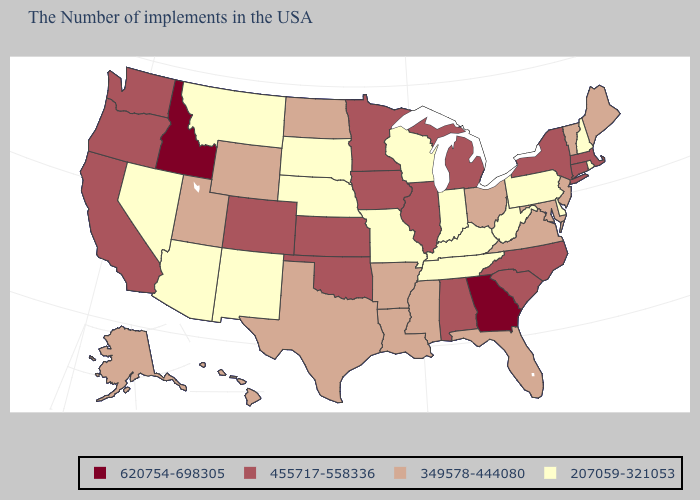What is the highest value in the MidWest ?
Write a very short answer. 455717-558336. Among the states that border Vermont , does Massachusetts have the highest value?
Be succinct. Yes. Name the states that have a value in the range 455717-558336?
Concise answer only. Massachusetts, Connecticut, New York, North Carolina, South Carolina, Michigan, Alabama, Illinois, Minnesota, Iowa, Kansas, Oklahoma, Colorado, California, Washington, Oregon. Does Utah have the highest value in the USA?
Write a very short answer. No. What is the lowest value in the West?
Concise answer only. 207059-321053. Does Tennessee have a lower value than Delaware?
Short answer required. No. What is the lowest value in states that border South Dakota?
Answer briefly. 207059-321053. Does Tennessee have a lower value than Missouri?
Write a very short answer. No. Among the states that border New Hampshire , does Vermont have the lowest value?
Concise answer only. Yes. Name the states that have a value in the range 349578-444080?
Write a very short answer. Maine, Vermont, New Jersey, Maryland, Virginia, Ohio, Florida, Mississippi, Louisiana, Arkansas, Texas, North Dakota, Wyoming, Utah, Alaska, Hawaii. How many symbols are there in the legend?
Short answer required. 4. Name the states that have a value in the range 207059-321053?
Write a very short answer. Rhode Island, New Hampshire, Delaware, Pennsylvania, West Virginia, Kentucky, Indiana, Tennessee, Wisconsin, Missouri, Nebraska, South Dakota, New Mexico, Montana, Arizona, Nevada. What is the value of Louisiana?
Concise answer only. 349578-444080. What is the lowest value in states that border Illinois?
Write a very short answer. 207059-321053. 